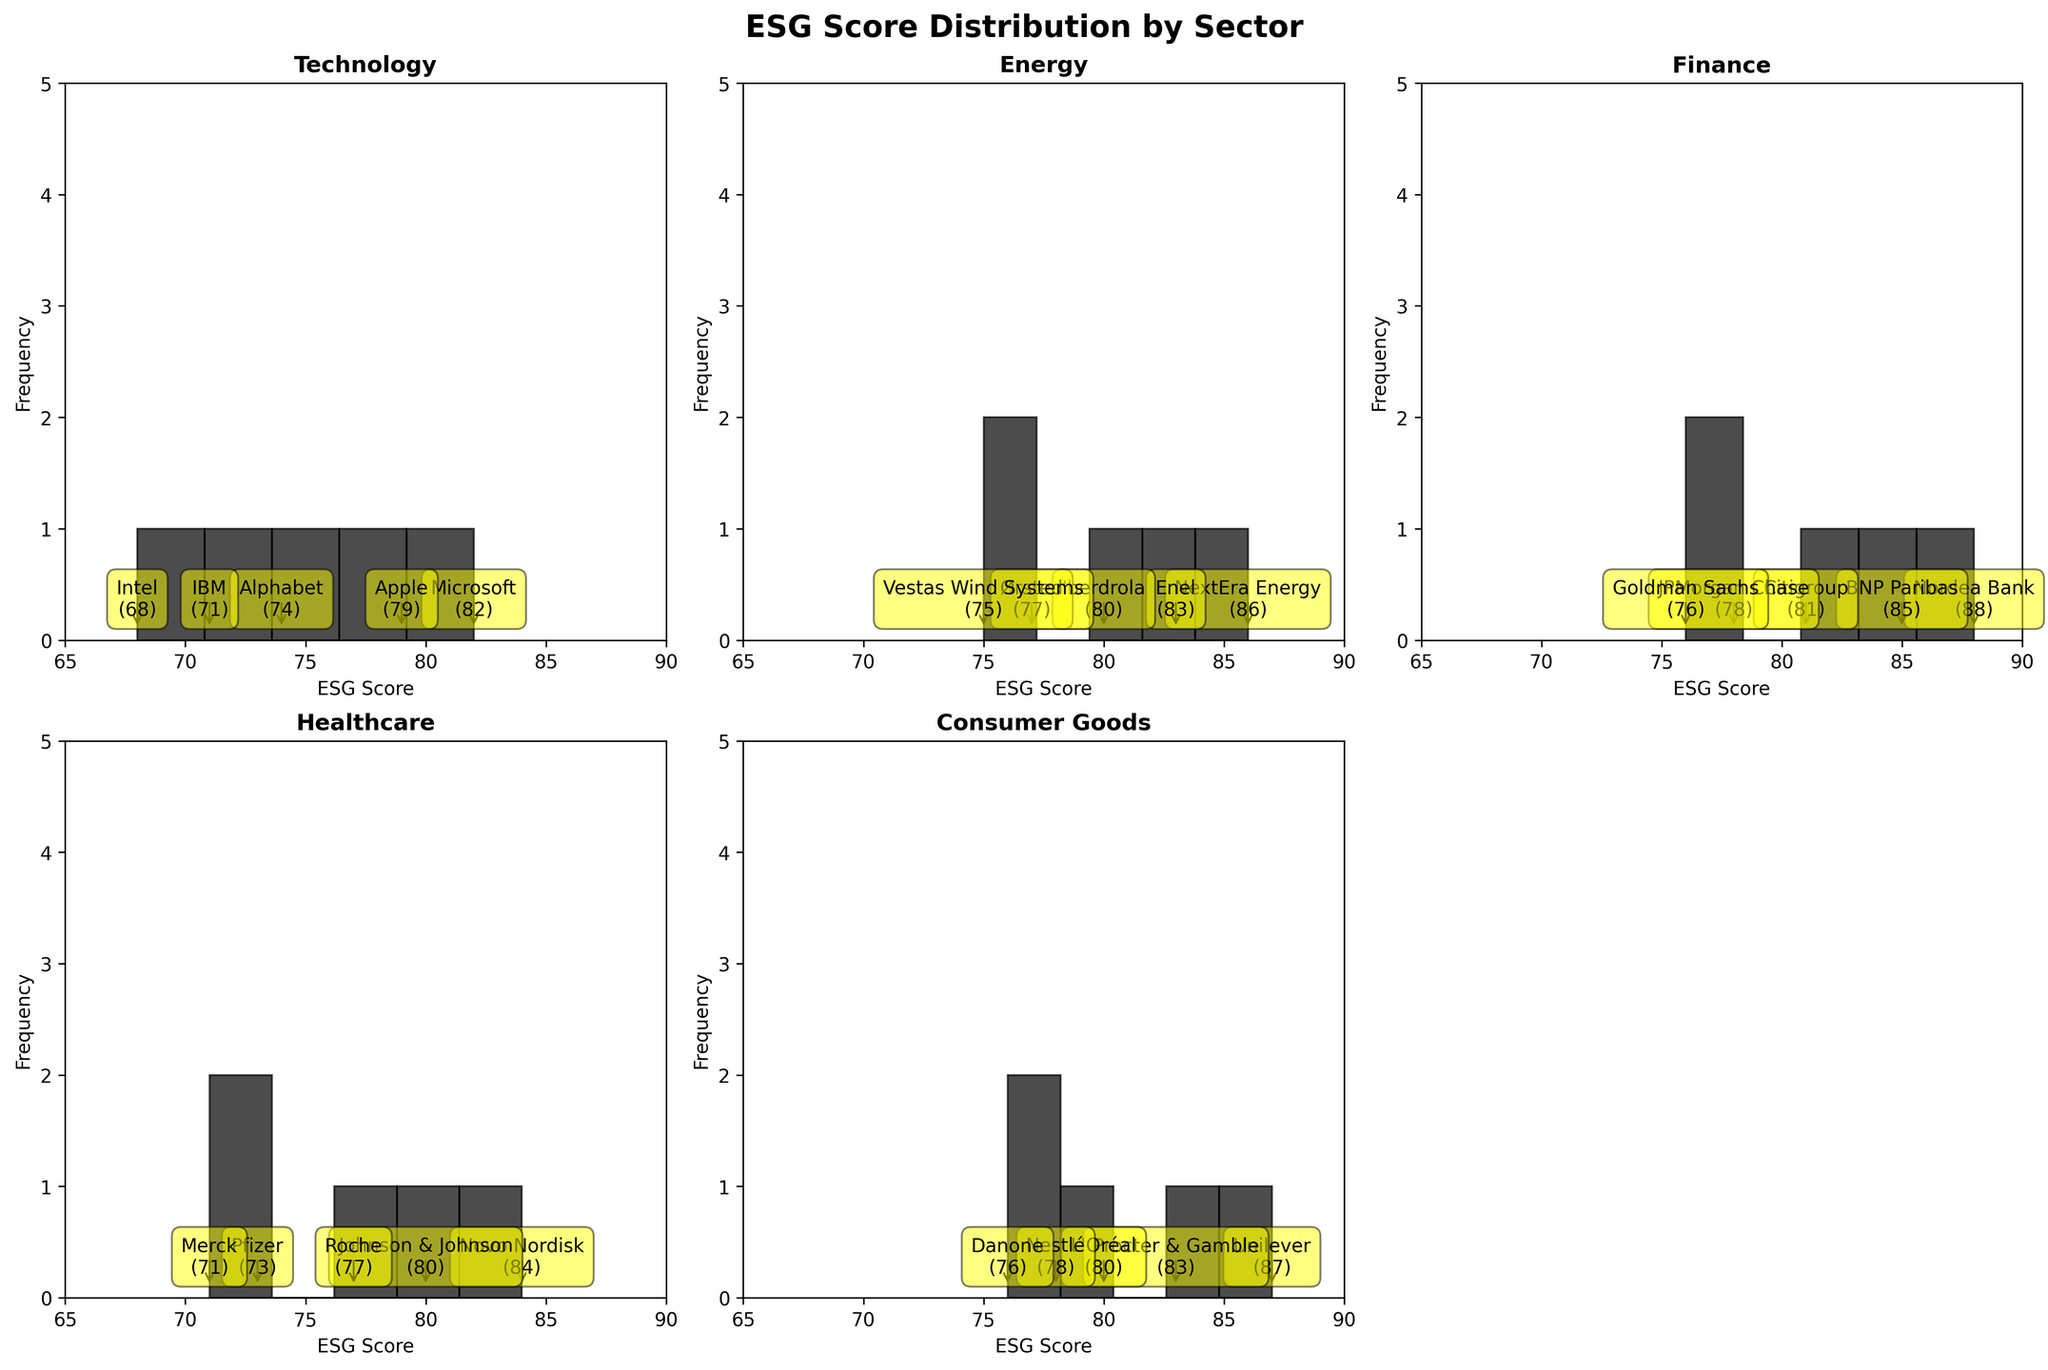What's the title of the figure? The title is located at the top of the figure and is typically bold and larger in font size compared to other texts. This helps viewers quickly identify the topic of the figure.
Answer: ESG Score Distribution by Sector How many different sectors are included in the figure? The number of sectors can be identified by counting the individual subplots, each labeled with a sector name. The last subplot is absent as it was removed in the code, indicating an odd number of sectors.
Answer: 6 Which company has the highest ESG score in the Energy sector? The highest ESG score in the Energy sector can be found by looking at the annotations on the histogram bars within the Energy subplot. The company associated with the highest bar and score will be the answer.
Answer: NextEra Energy What is the range of ESG scores in the Consumer Goods sector? The range can be determined by identifying the highest and lowest ESG scores in the Consumer Goods sector's histogram. The highest score is 87 (Unilever) and the lowest score is 76 (Danone). The range is the difference between these two values.
Answer: 11 Which sector has the widest range of ESG scores? To find the widest range, compare the score ranges (highest minus lowest values) for each sector's histogram. Technology has the widest range as the scores vary from 68 to 82, yielding a range of 14.
Answer: Technology Which sector has the highest average ESG score? Calculate the average ESG score for each sector by summing all scores within a sector and dividing by the number of companies. The Finance sector has the highest average, calculated as (88 + 85 + 81 + 78 + 76) / 5 = 81.6.
Answer: Finance How many companies in the Healthcare sector have ESG scores above 75? Count the number of companies in the Healthcare sector whose scores are above the 75 value in the histogram. We find that 3 companies (Novo Nordisk, Johnson & Johnson, Roche) have scores above 75.
Answer: 3 Which companies have ESG scores equal to or greater than 85 in their respective sectors? Identify the companies whose scores are equal to or greater than 85 in each sector by checking the annotations near the top of the histogram bars. The companies are: Nordea Bank (Finance), BNP Paribas (Finance), NextEra Energy (Energy), Enel (Energy), Tesla (Automotive), BMW (Automotive), Unilever (Consumer Goods).
Answer: Nordea Bank, BNP Paribas, NextEra Energy, Enel, Tesla, BMW, Unilever Between Technology and Automotive sectors, which one has more companies with ESG scores above 80? Count the companies with scores above 80 in both the Technology and Automotive sectors. Technology has 2 companies (Microsoft, Apple), while Automotive has 3 companies (Tesla, BMW, Volkswagen).
Answer: Automotive 